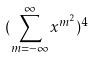<formula> <loc_0><loc_0><loc_500><loc_500>( \sum _ { m = - \infty } ^ { \infty } x ^ { m ^ { 2 } } ) ^ { 4 }</formula> 